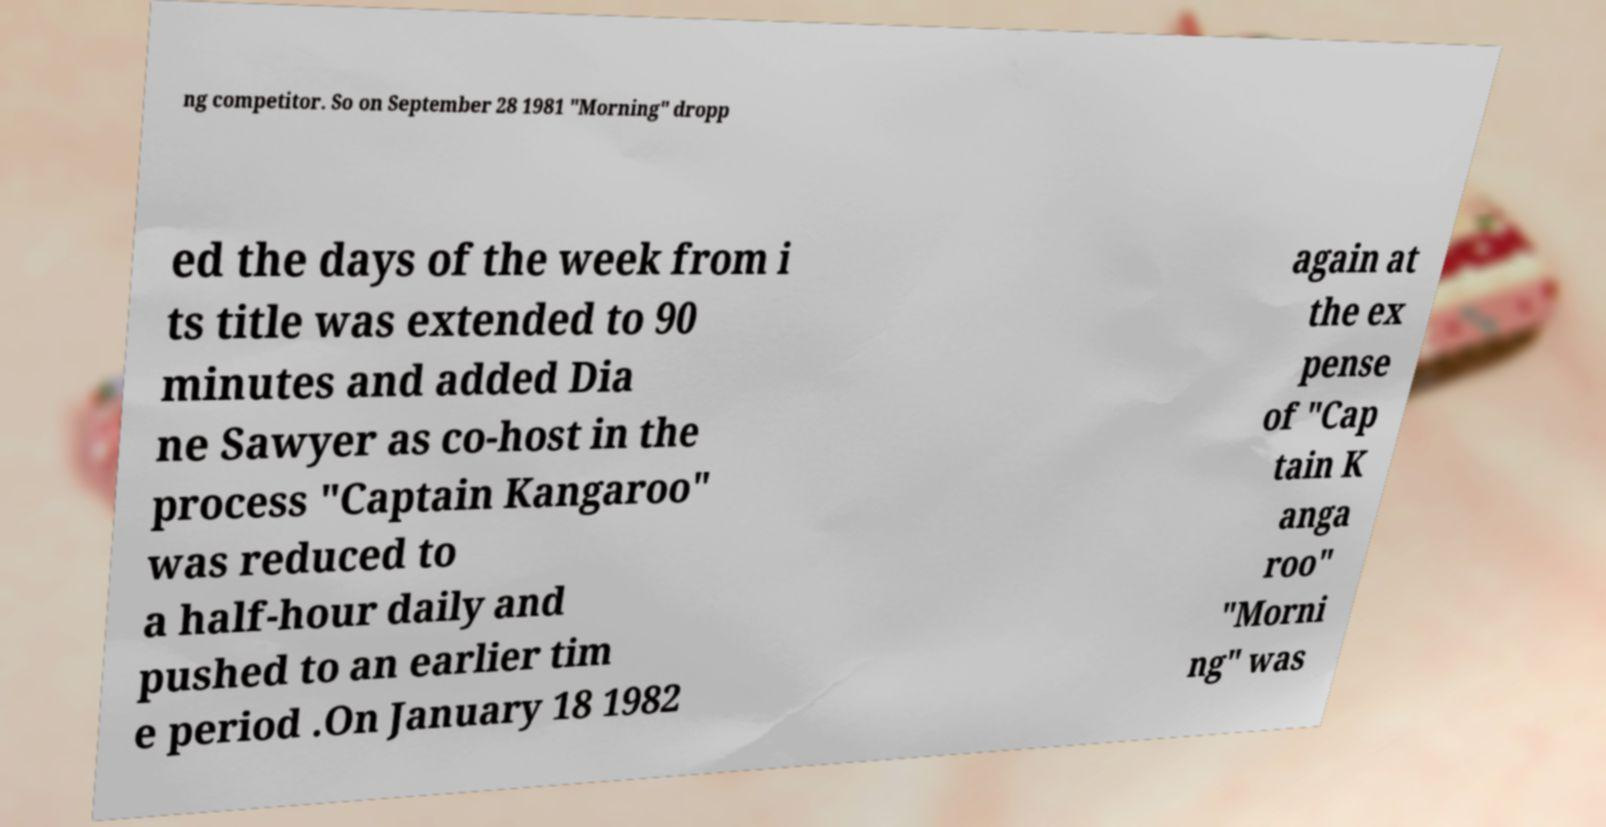Please read and relay the text visible in this image. What does it say? ng competitor. So on September 28 1981 "Morning" dropp ed the days of the week from i ts title was extended to 90 minutes and added Dia ne Sawyer as co-host in the process "Captain Kangaroo" was reduced to a half-hour daily and pushed to an earlier tim e period .On January 18 1982 again at the ex pense of "Cap tain K anga roo" "Morni ng" was 